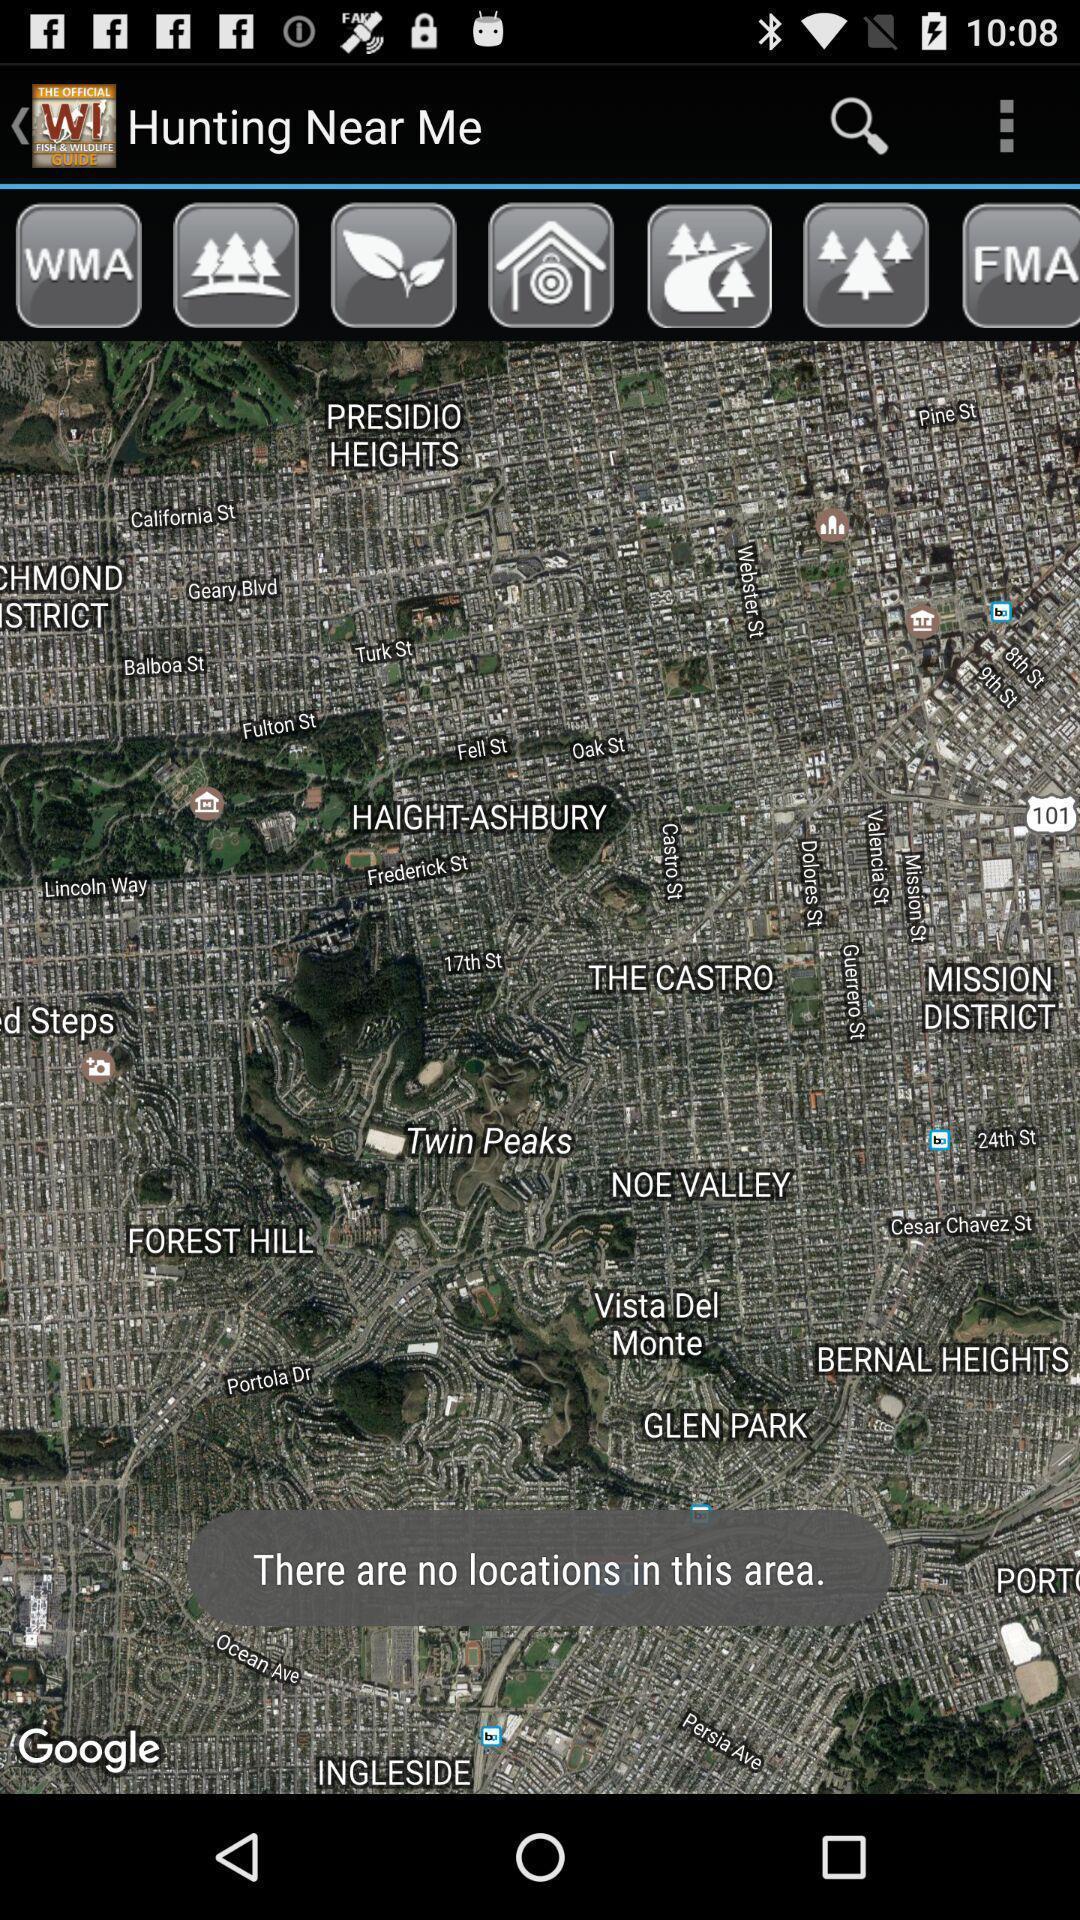Tell me what you see in this picture. Page displaying the game of hunting near me. 